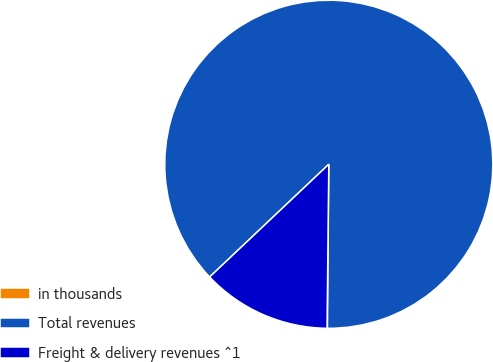Convert chart to OTSL. <chart><loc_0><loc_0><loc_500><loc_500><pie_chart><fcel>in thousands<fcel>Total revenues<fcel>Freight & delivery revenues ^1<nl><fcel>0.04%<fcel>87.19%<fcel>12.77%<nl></chart> 